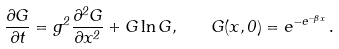Convert formula to latex. <formula><loc_0><loc_0><loc_500><loc_500>\frac { \partial G } { \partial t } = g ^ { 2 } \frac { \partial ^ { 2 } G } { \partial x ^ { 2 } } + G \ln { G } , \quad G ( x , 0 ) = e ^ { - e ^ { - \beta x } } \, .</formula> 